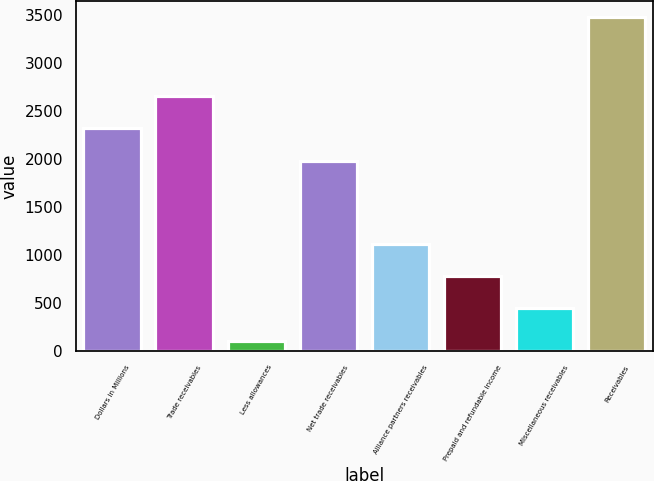<chart> <loc_0><loc_0><loc_500><loc_500><bar_chart><fcel>Dollars in Millions<fcel>Trade receivables<fcel>Less allowances<fcel>Net trade receivables<fcel>Alliance partners receivables<fcel>Prepaid and refundable income<fcel>Miscellaneous receivables<fcel>Receivables<nl><fcel>2322.3<fcel>2659.6<fcel>107<fcel>1985<fcel>1118.9<fcel>781.6<fcel>444.3<fcel>3480<nl></chart> 